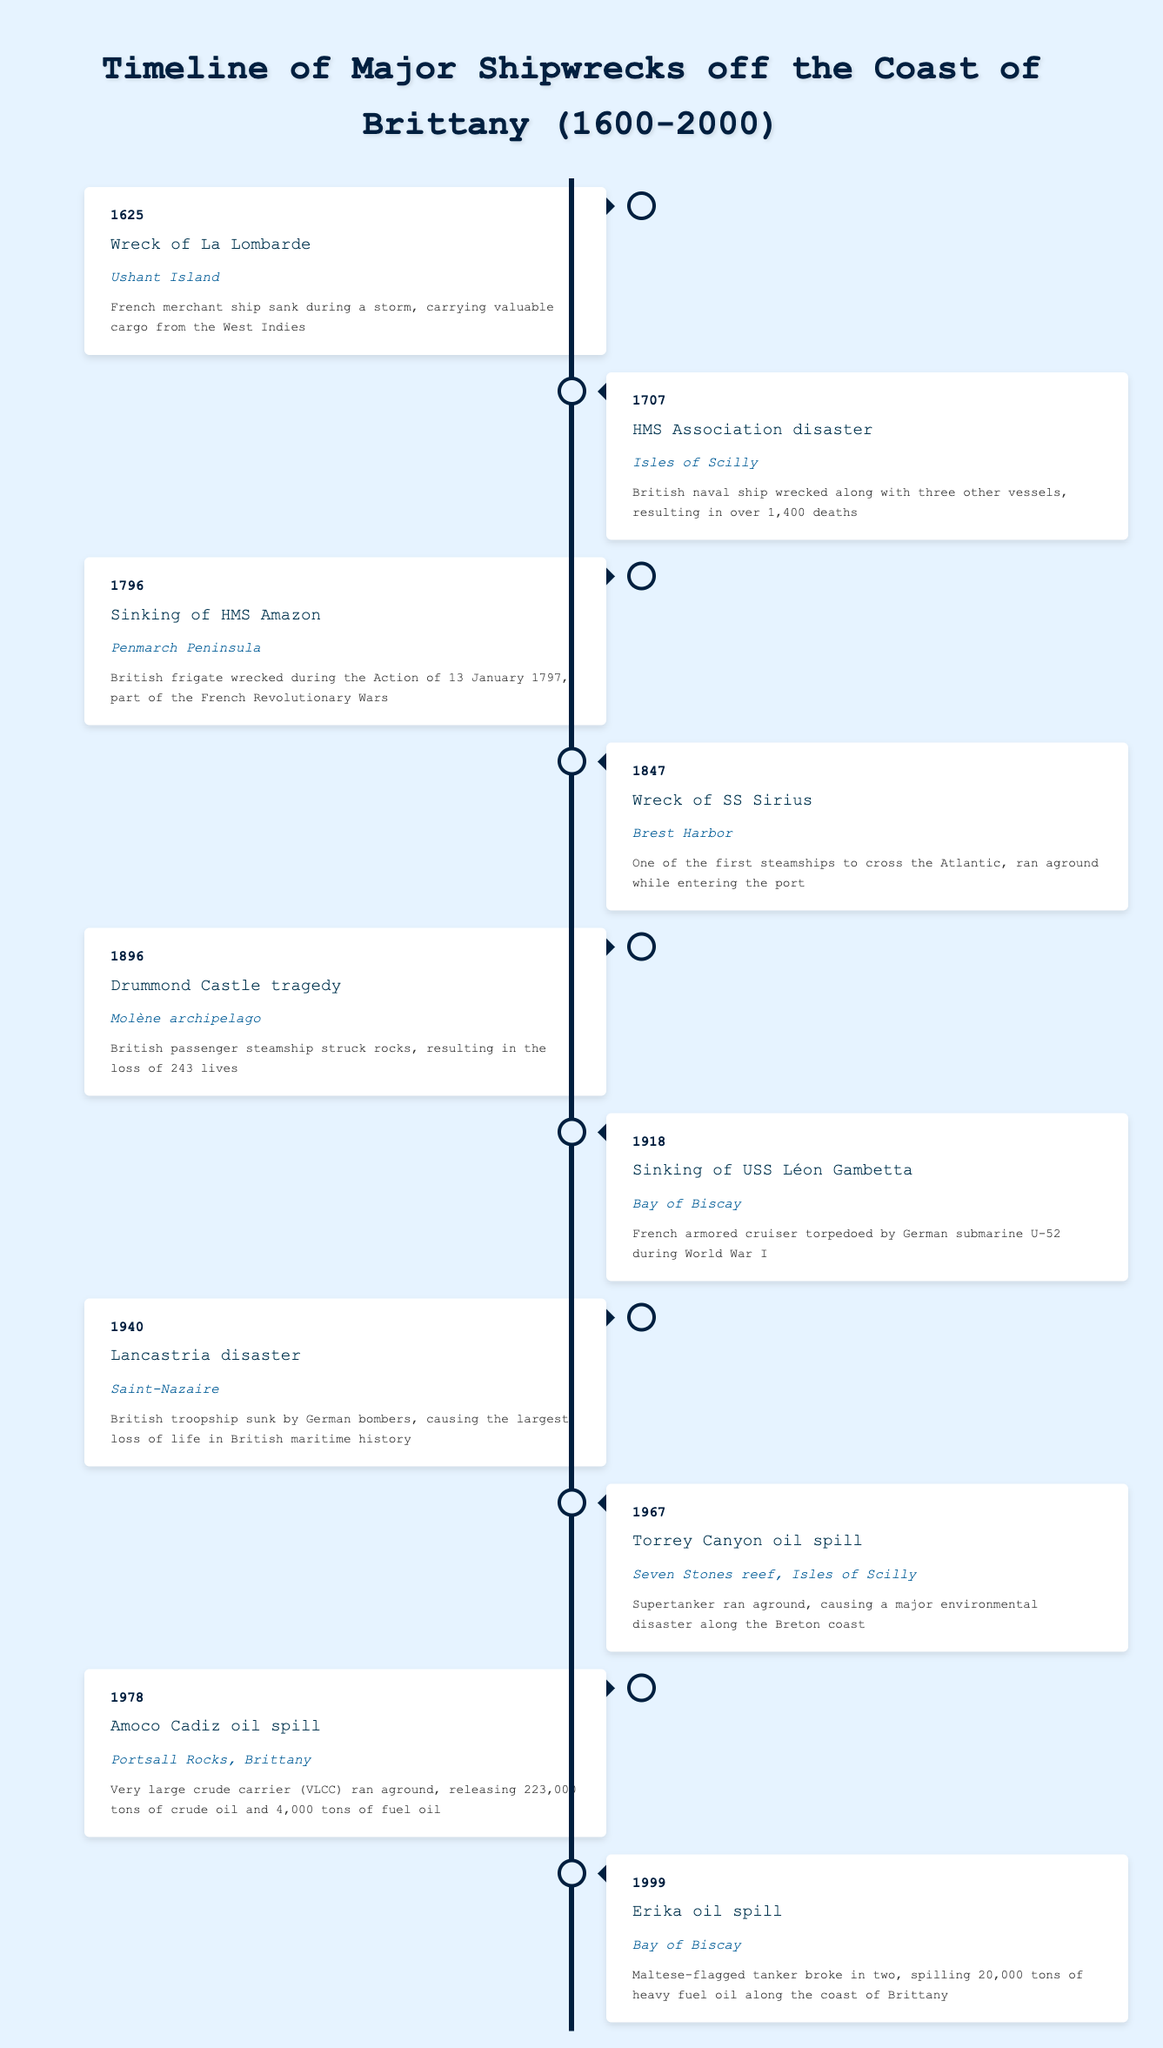What year did the wreck of La Lombarde occur? The table lists the event "Wreck of La Lombarde" occurring in the year 1625. The answer is found directly in the "year" column for that event.
Answer: 1625 Where did the Lancastria disaster take place? The table shows the "Lancastria disaster" occurring at "Saint-Nazaire". This is found in the "location" column for that event.
Answer: Saint-Nazaire How many lives were lost in the Drummond Castle tragedy? The tragedy is recorded as resulting in the loss of 243 lives, as stated in the description of the event in the table.
Answer: 243 Which shipwreck event has the largest recorded loss of life? The "Lancastria disaster" is noted for causing the largest loss of life in British maritime history. Thus, by checking the descriptions, this becomes clear.
Answer: Lancastria disaster How many shipwrecks listed occurred before the 1800s? There are three events listed: the Wreck of La Lombarde (1625), the HMS Association disaster (1707), and the sinking of HMS Amazon (1796) before the year 1800. Counting these events gives us 3.
Answer: 3 Is the Torrey Canyon disaster the only disaster that caused significant environmental damage off the Brittany coast? The described events indicate that both the Torrey Canyon oil spill (1967) and the Amoco Cadiz oil spill (1978) caused major environmental disasters. Since more than one event fits this description, the answer is “no”.
Answer: No How many shipwrecks occurred in the 20th century? The 20th century events include the sinking of USS Léon Gambetta (1918), the Lancastria disaster (1940), the Torrey Canyon oil spill (1967), the Amoco Cadiz oil spill (1978), and the Erika oil spill (1999). Counting these gives us five events.
Answer: 5 Which event occurred last in the timeline? The table reveals that the last event listed is the Erika oil spill, which happened in 1999. This is verified by looking at the years in chronological order.
Answer: Erika oil spill Is the sinking of HMS Amazon related to the French Revolutionary Wars? The description for HMS Amazon states that it was wrecked during the Action related to the French Revolutionary Wars, confirming this connection. Thus, the answer is "yes".
Answer: Yes 